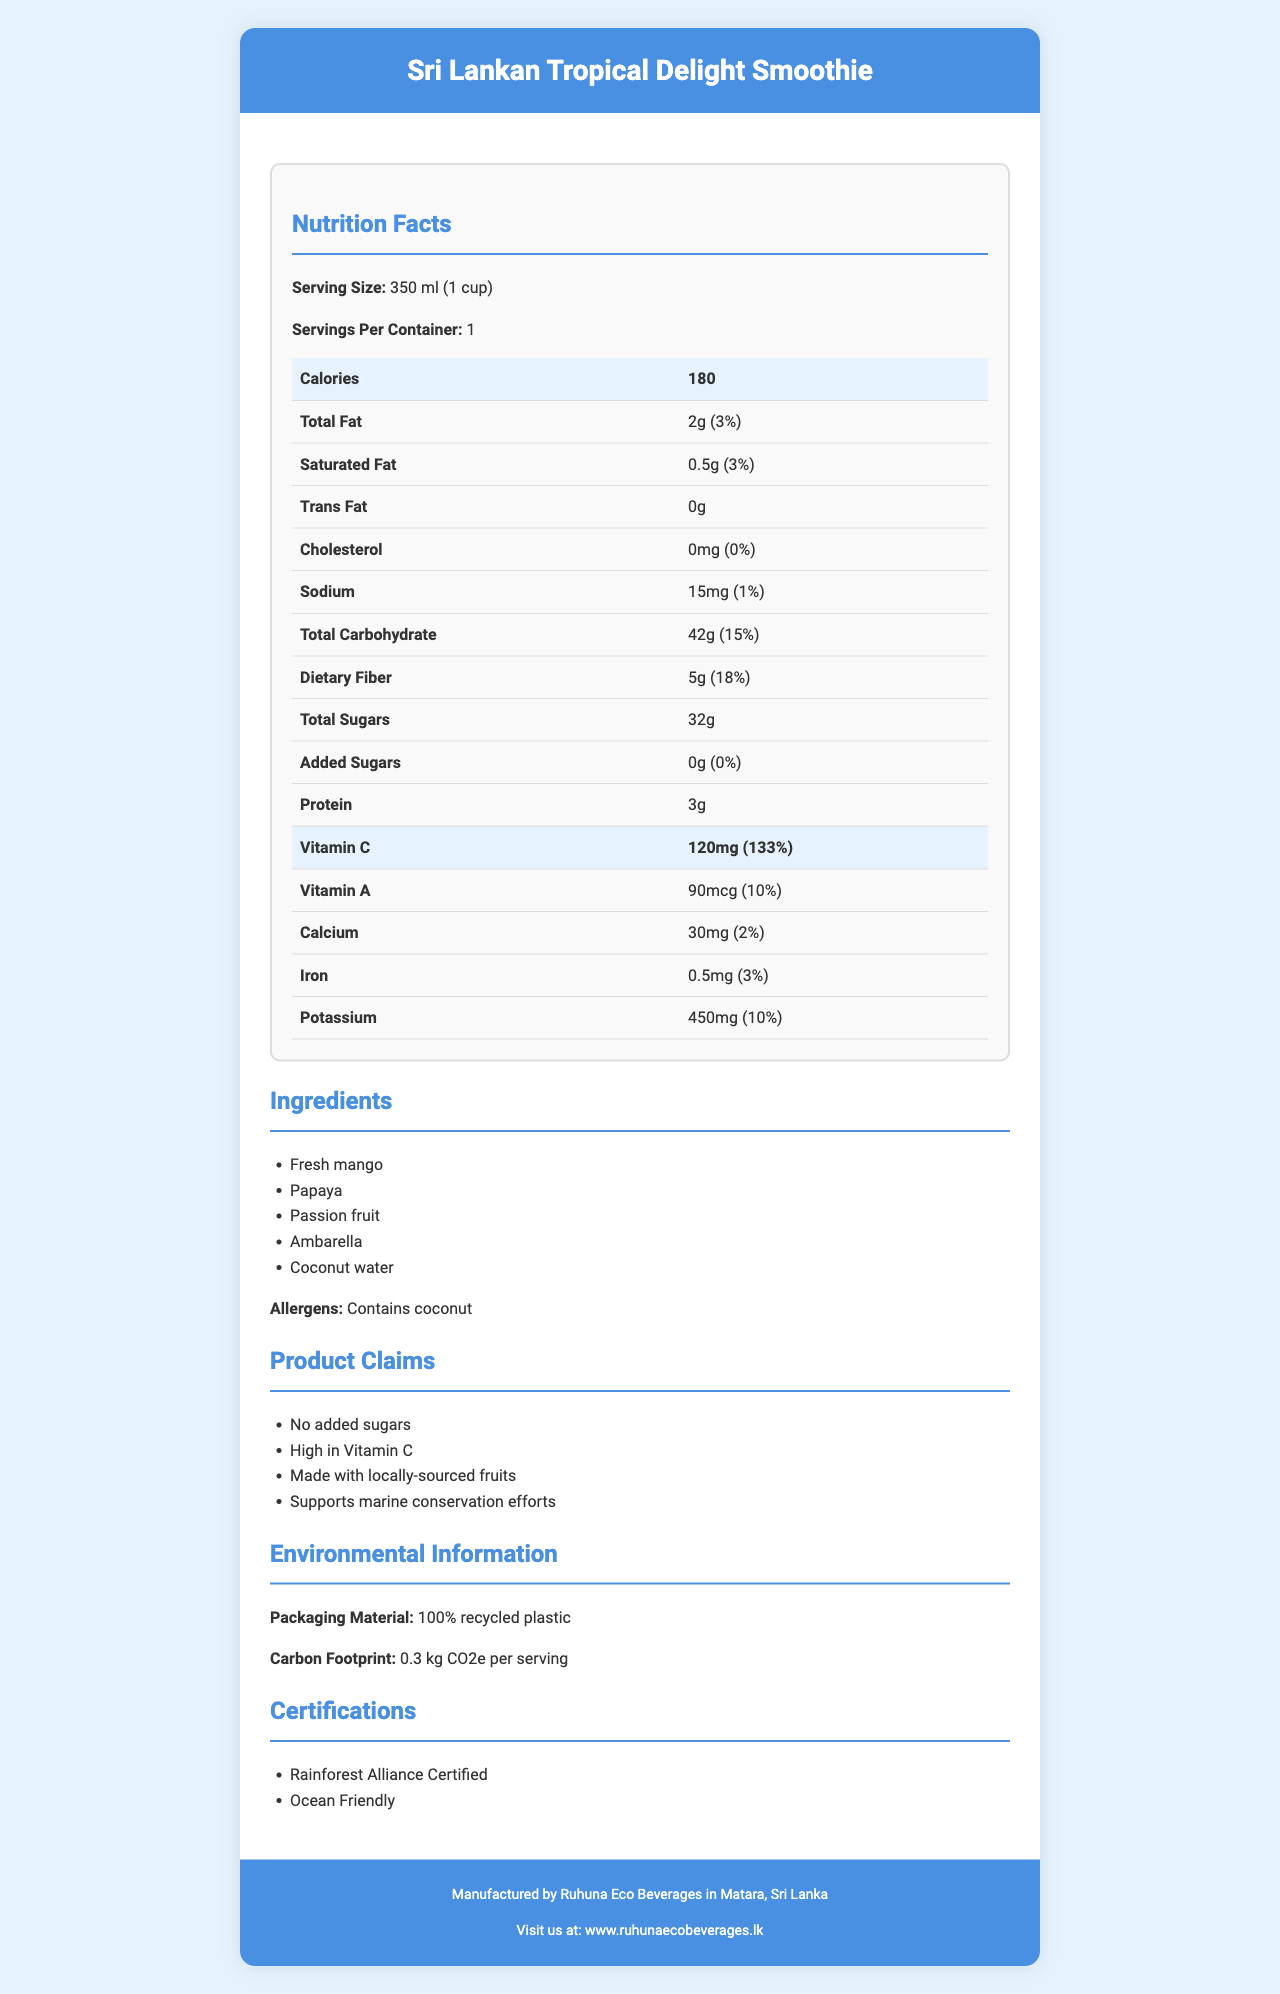What is the serving size of the Sri Lankan Tropical Delight Smoothie? The serving size is explicitly mentioned as "350 ml (1 cup)" in the nutrition facts section of the document.
Answer: 350 ml (1 cup) How many calories are in one serving of the Sri Lankan Tropical Delight Smoothie? The document states that each serving contains 180 calories.
Answer: 180 calories How much vitamin C is in one serving of the smoothie? According to the document, the amount of vitamin C is listed as 120 mg.
Answer: 120 mg What is the daily value percentage of vitamin C in the smoothie? The document indicates that the daily value percentage of vitamin C in one serving is 133%.
Answer: 133% List the fruits used in the Sri Lankan Tropical Delight Smoothie. The ingredients section of the document lists these fruits as the main components of the smoothie.
Answer: Fresh mango, Papaya, Passion fruit, Ambarella What is the total carbohydrate content per serving? The document specifies that the total carbohydrate content is 42g per serving.
Answer: 42g How much dietary fiber does the smoothie contain? According to the document, the dietary fiber content in one serving is 5g.
Answer: 5g Does the smoothie contain any added sugars? The document states the added sugars amount is 0g, indicating there are no added sugars.
Answer: No What allergens are present in the smoothie? The allergens section specifies "Contains coconut."
Answer: Contains coconut How does the smoothie support sustainability? The claims section mentions that the product supports marine conservation efforts.
Answer: Supports marine conservation efforts Which of the following is NOT an ingredient in the smoothie? A. Fresh mango B. Banana C. Passion fruit The list of ingredients does not mention banana.
Answer: B. Banana What is the main commentary about the environmental impact of the packaging material? A. It uses recycled plastic. B. It uses biodegradable material. C. It has no environmental impacts. The environmental information section states that the packaging material is "100% recycled plastic".
Answer: A. It uses recycled plastic. Does the smoothie contribute any trans fat? The document states the trans fat content is 0g.
Answer: No Summarize the main nutritional and environmental benefits of the Sri Lankan Tropical Delight Smoothie. This summary captures the key nutritional and environmental benefits highlighted in the document.
Answer: The smoothie is high in vitamin C, containing 120 mg per serving (133% DV). It provides 180 calories per serving, with a notable amount of dietary fiber (5g). It contains no added sugars or trans fat and supports marine conservation efforts. The packaging is made from 100% recycled plastic and has a low carbon footprint of 0.3 kg CO2e per serving. Who manufactures the Sri Lankan Tropical Delight Smoothie? The footer section of the document includes the manufacturer information, indicating it is produced by Ruhuna Eco Beverages.
Answer: Ruhuna Eco Beverages What is the sodium content in one serving of the smoothie? The document specifies that the sodium content per serving is 15mg.
Answer: 15mg How much potassium does the smoothie provide per serving? The document states that the potassium amount per serving is 450mg.
Answer: 450mg Can the carbon footprint of this smoothie be determined from the document? The carbon footprint is listed as 0.3 kg CO2e per serving in the environmental information section.
Answer: Yes What certifications does the smoothie have? The certifications section of the document lists these two certifications.
Answer: Rainforest Alliance Certified, Ocean Friendly What is the primary location of the manufacturer? The footer of the document specifies that the manufacturer, Ruhuna Eco Beverages, is located in Matara, Sri Lanka.
Answer: Matara, Sri Lanka How much added sugars does the smoothie have as a percentage of the daily value? The document states that the added sugars amount is 0g, corresponding to 0% of the daily value.
Answer: 0% What type of material is used for the packaging? According to the environmental information section, the packaging is made from 100% recycled plastic.
Answer: 100% recycled plastic What is the protein content in one serving of the smoothie? The document indicates that the protein content per serving is 3g.
Answer: 3g What is the website for Ruhuna Eco Beverages? The footer section provides the website address for the manufacturer.
Answer: www.ruhunaecobeverages.lk 